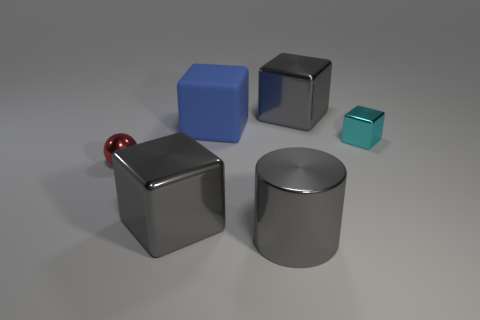How many blocks have the same material as the big cylinder?
Provide a succinct answer. 3. Is there a tiny red sphere behind the gray block to the right of the gray metallic thing to the left of the large matte block?
Provide a succinct answer. No. The blue rubber object has what shape?
Your answer should be very brief. Cube. Is the ball that is in front of the matte thing made of the same material as the large gray object that is behind the small cyan object?
Provide a short and direct response. Yes. What number of large objects have the same color as the large metal cylinder?
Your response must be concise. 2. There is a thing that is right of the large matte cube and in front of the small cyan shiny cube; what is its shape?
Offer a terse response. Cylinder. There is a shiny thing that is in front of the tiny ball and to the left of the big blue matte thing; what color is it?
Ensure brevity in your answer.  Gray. Is the number of shiny blocks that are in front of the large gray metallic cylinder greater than the number of gray cubes in front of the red metallic thing?
Your answer should be very brief. No. There is a tiny metallic thing right of the matte thing; what color is it?
Offer a very short reply. Cyan. There is a tiny object that is in front of the small cyan shiny thing; does it have the same shape as the small shiny thing that is right of the red metallic thing?
Provide a succinct answer. No. 